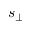<formula> <loc_0><loc_0><loc_500><loc_500>s _ { \bot }</formula> 